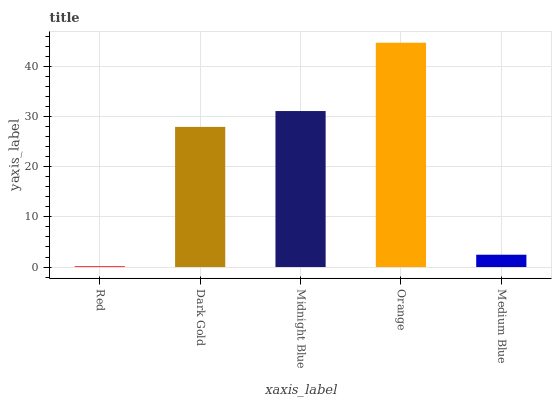Is Red the minimum?
Answer yes or no. Yes. Is Orange the maximum?
Answer yes or no. Yes. Is Dark Gold the minimum?
Answer yes or no. No. Is Dark Gold the maximum?
Answer yes or no. No. Is Dark Gold greater than Red?
Answer yes or no. Yes. Is Red less than Dark Gold?
Answer yes or no. Yes. Is Red greater than Dark Gold?
Answer yes or no. No. Is Dark Gold less than Red?
Answer yes or no. No. Is Dark Gold the high median?
Answer yes or no. Yes. Is Dark Gold the low median?
Answer yes or no. Yes. Is Red the high median?
Answer yes or no. No. Is Medium Blue the low median?
Answer yes or no. No. 